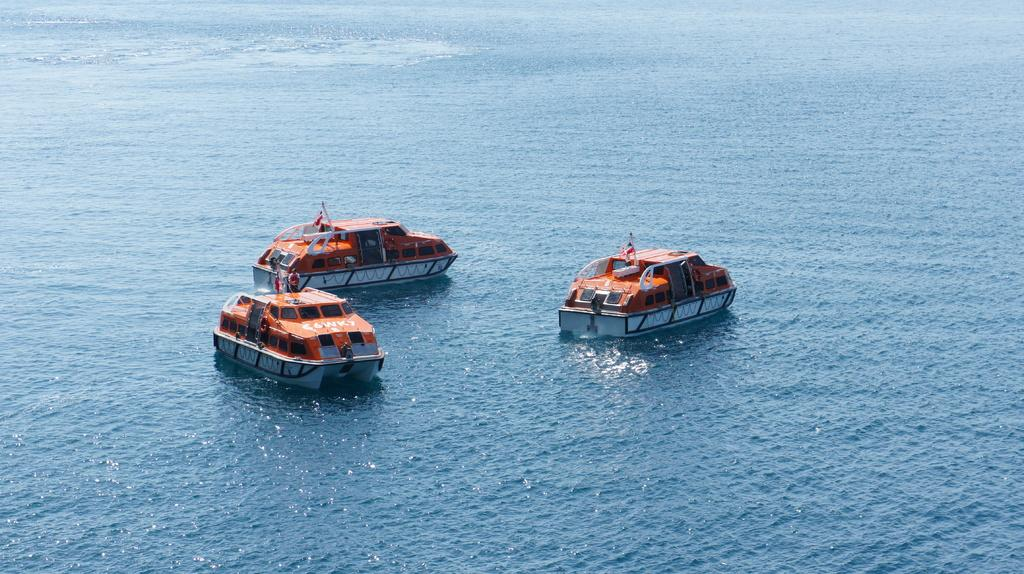What is the main subject of the image? The main subject of the image is ships. Where are the ships located in the image? The ships are in the center of the image. What is the ships' environment in the image? The ships are on water. How many apples can be seen floating near the ships in the image? There are no apples present in the image; it features ships on water. What type of rest can be seen being taken by the goose in the image? There is no goose present in the image, as it only features ships on water. 